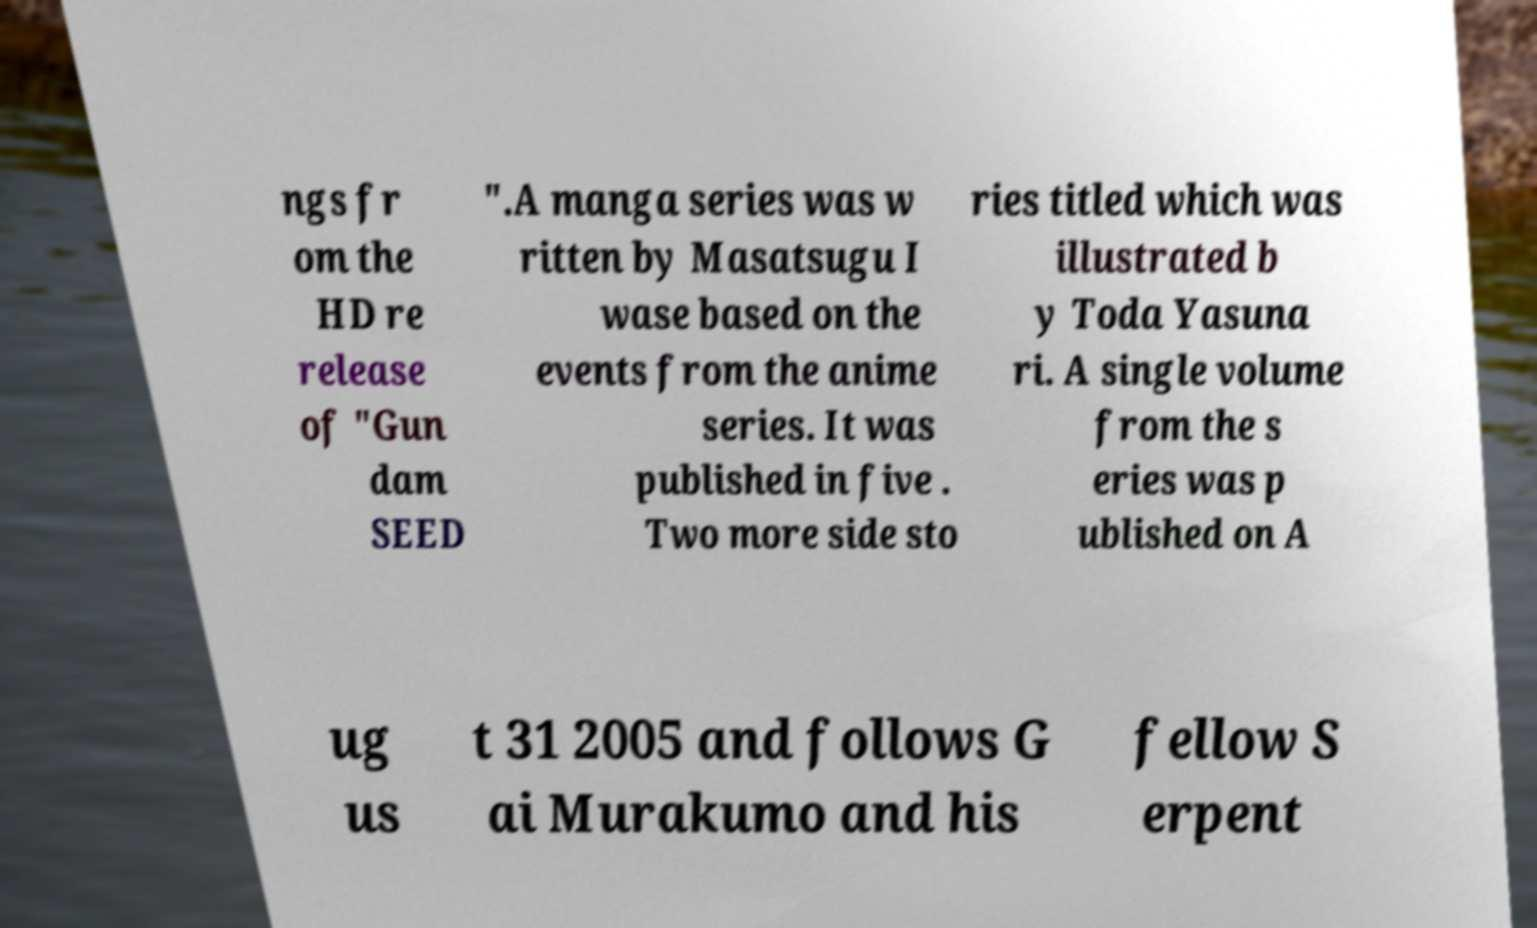Please identify and transcribe the text found in this image. ngs fr om the HD re release of "Gun dam SEED ".A manga series was w ritten by Masatsugu I wase based on the events from the anime series. It was published in five . Two more side sto ries titled which was illustrated b y Toda Yasuna ri. A single volume from the s eries was p ublished on A ug us t 31 2005 and follows G ai Murakumo and his fellow S erpent 